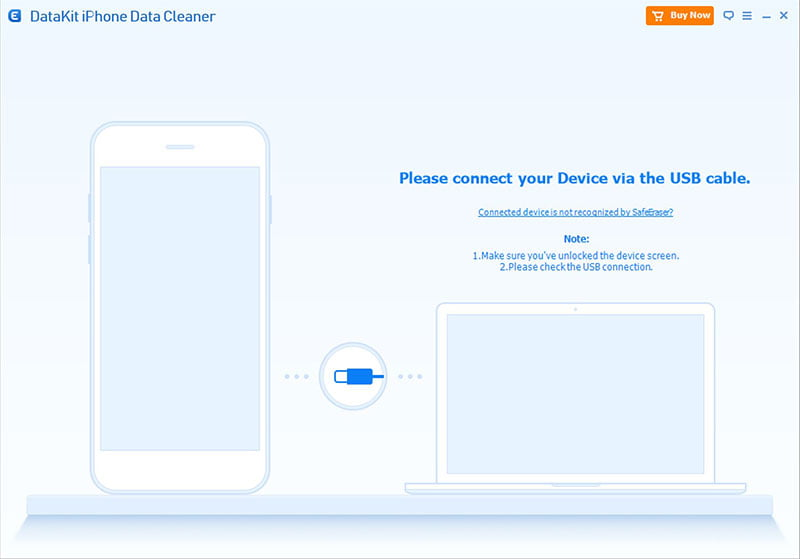Imagine if the software transformed into a virtual assistant, what would it say upon detecting connection issues? Hello! It seems like there’s a hiccup in establishing a connection between your device and the software. Let’s troubleshoot this together! First, please unlock your device screen. This allows me to access the necessary data. Then, let’s ensure the USB cable is snugly connected on both ends. If these steps don’t help, don't worry; I’ve got more tricks up my sleeve to solve this. Just let me know how you’d like to proceed! What kind of tips can this virtual assistant provide spontaneously in case of repeated connection failures? If connection issues persist, the virtual assistant can provide several spontaneous tips and solutions:
1. **Suggest Restarting the Devices:** 'Perhaps a quick restart of your phone and computer might help clear up any temporary glitches.'
2. **Cable Check:** 'Just to be thorough, let’s double-check if the USB cable is in good condition and connected properly. Trying a different cable might also help.'
3. **Driver Update:** 'We might need to update or reinstall the device drivers on your computer. I can guide you through this process step-by-step.'
4. **Alternate USB Port:** 'Sometimes switching to another USB port can make a difference. Let’s try connecting the cable to a different USB slot on your computer.'
5. **USB Debugging:** 'Ensuring USB debugging is enabled can be vital for a stable connection. I can help you find the settings to enable this.'
6. **Check for Conflicting Software:** 'Other software on your computer might be interfering with the connection. Let’s close unnecessary applications and try again.'
7. **Consult Additional Resources:** 'If we’re still facing challenges, referring to the user manual or reaching out to technical support could provide further assistance.'
The virtual assistant strives to troubleshoot efficiently, aiming to resolve the issues amicably for a seamless user experience. What if the virtual assistant could show emotions? Describe its reaction if the connection is successfully established after struggling for a while. With an expressive interface, the virtual assistant would show immense relief and joy upon successfully establishing the connection. It would likely exclaim, 'Hooray! We did it! The connection is now established, and we’re ready to roll. Thanks for your patience and teamwork!' An animated virtual assistant might even display celebratory visuals, such as confetti or a cheerful dance, to express its delight in overcoming the connectivity challenge together with the user. 